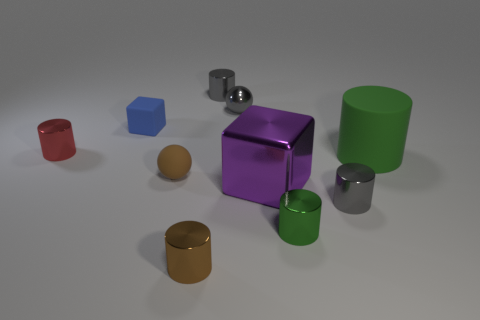What is the shape of the metallic thing that is the same color as the rubber cylinder?
Provide a short and direct response. Cylinder. What number of metallic things have the same color as the large rubber thing?
Your answer should be compact. 1. There is a tiny metallic ball; does it have the same color as the cylinder behind the metallic ball?
Keep it short and to the point. Yes. What color is the object right of the gray cylinder that is right of the green cylinder that is in front of the large cylinder?
Provide a short and direct response. Green. How many other objects are the same color as the shiny sphere?
Make the answer very short. 2. Is the number of small shiny balls less than the number of small green cubes?
Ensure brevity in your answer.  No. The thing that is both left of the brown cylinder and in front of the green rubber cylinder is what color?
Provide a succinct answer. Brown. There is a tiny green object that is the same shape as the tiny red shiny thing; what material is it?
Make the answer very short. Metal. Is there anything else that is the same size as the green rubber cylinder?
Provide a short and direct response. Yes. Is the number of matte spheres greater than the number of big red blocks?
Offer a very short reply. Yes. 